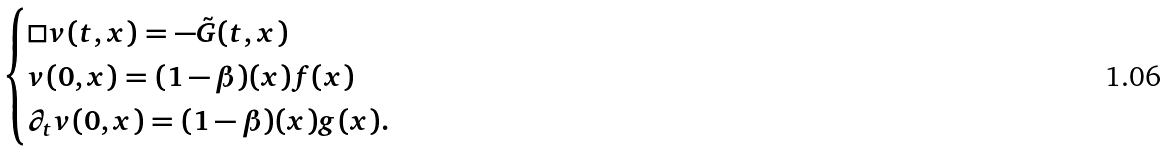<formula> <loc_0><loc_0><loc_500><loc_500>\begin{cases} \Box v ( t , x ) = - \tilde { G } ( t , x ) \\ v ( 0 , x ) = ( 1 - \beta ) ( x ) f ( x ) \\ \partial _ { t } v ( 0 , x ) = ( 1 - \beta ) ( x ) g ( x ) . \end{cases}</formula> 